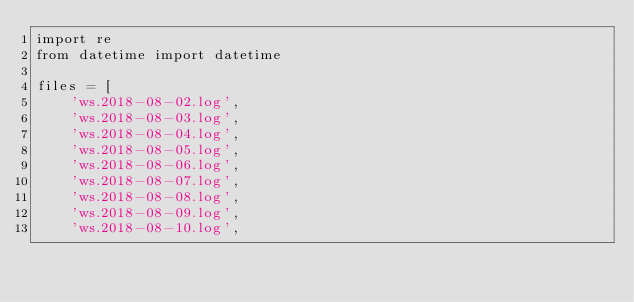Convert code to text. <code><loc_0><loc_0><loc_500><loc_500><_Python_>import re
from datetime import datetime

files = [
    'ws.2018-08-02.log',
    'ws.2018-08-03.log',
    'ws.2018-08-04.log',
    'ws.2018-08-05.log',
    'ws.2018-08-06.log',
    'ws.2018-08-07.log',
    'ws.2018-08-08.log',
    'ws.2018-08-09.log',
    'ws.2018-08-10.log',</code> 